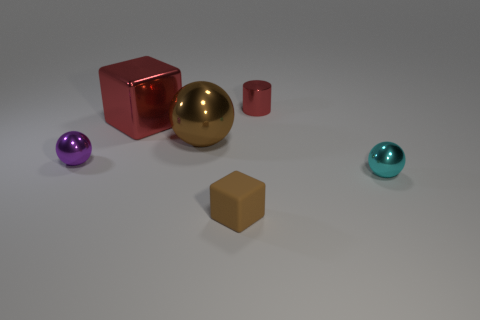Is there a big red metallic object that is right of the cube that is behind the cyan sphere?
Give a very brief answer. No. Is the number of tiny things that are right of the small red metal cylinder less than the number of objects behind the tiny purple metallic sphere?
Your answer should be very brief. Yes. Is there anything else that is the same size as the cylinder?
Your answer should be very brief. Yes. There is a tiny matte object; what shape is it?
Provide a short and direct response. Cube. There is a big block in front of the cylinder; what material is it?
Provide a succinct answer. Metal. What size is the sphere on the right side of the red shiny object that is on the right side of the cube that is in front of the small cyan ball?
Ensure brevity in your answer.  Small. Does the brown object that is behind the brown block have the same material as the block that is right of the red shiny block?
Give a very brief answer. No. What number of other things are there of the same color as the large sphere?
Keep it short and to the point. 1. What number of things are either spheres in front of the small purple ball or small things behind the tiny cube?
Your response must be concise. 3. There is a metal ball that is in front of the tiny metal object that is to the left of the matte thing; what size is it?
Offer a terse response. Small. 